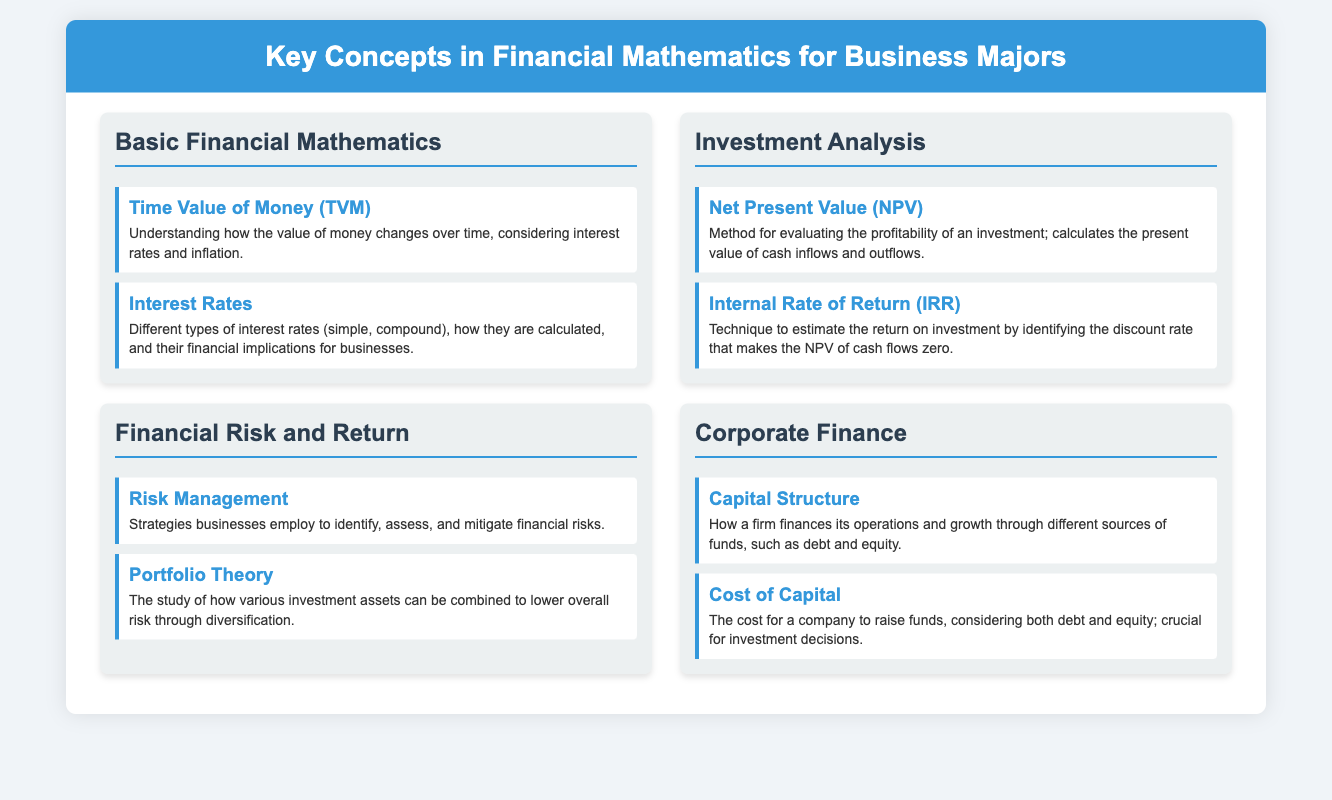What is the title of the document? The title of the document is prominently displayed at the top of the infographic.
Answer: Key Concepts in Financial Mathematics for Business Majors What is the first topic covered under Basic Financial Mathematics? The first topic listed in the Basic Financial Mathematics section is visible as the first component.
Answer: Time Value of Money (TVM) What does NPV stand for in Investment Analysis? NPV is an abbreviation mentioned in the Investment Analysis section and stands for Net Present Value.
Answer: Net Present Value What is a method used to evaluate investment profitability? The method described in the Investment Analysis section for evaluating profitability is clearly stated in one of the components.
Answer: Net Present Value (NPV) What is discussed under Financial Risk and Return? This section covers multiple components addressing financial risk management and investment diversification.
Answer: Risk Management What are the two main components of Corporate Finance? The Corporate Finance section contains two specific components that address critical elements of corporate finance.
Answer: Capital Structure and Cost of Capital Which concept aids in lowering overall investment risk? The concept outlined under Financial Risk and Return that is aimed at lowering investment risk is evident from the description.
Answer: Portfolio Theory What type of interest is mentioned in the context of Basic Financial Mathematics? The context includes different types of interest rates discussed under a specific component.
Answer: Compound What does IRR stand for in Investment Analysis? IRR is an abbreviation mentioned in the Investment Analysis section and stands for Internal Rate of Return.
Answer: Internal Rate of Return 